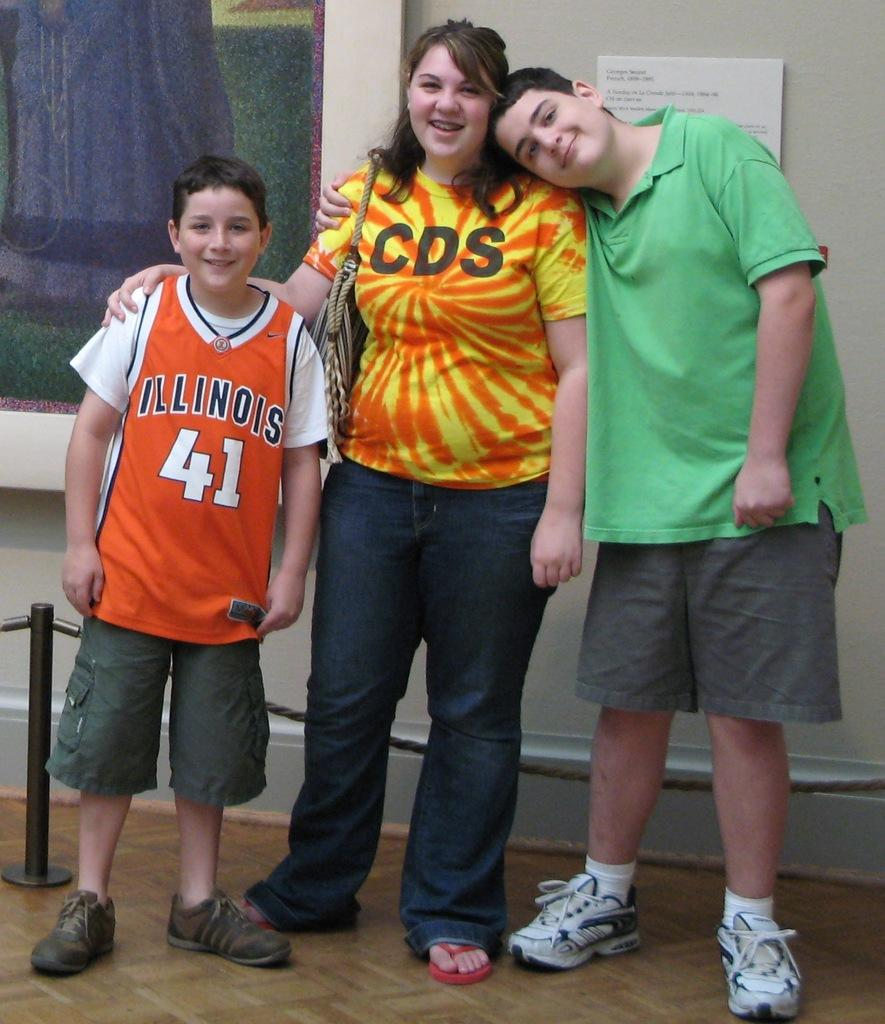<image>
Share a concise interpretation of the image provided. a woman that has cds on their shirt 